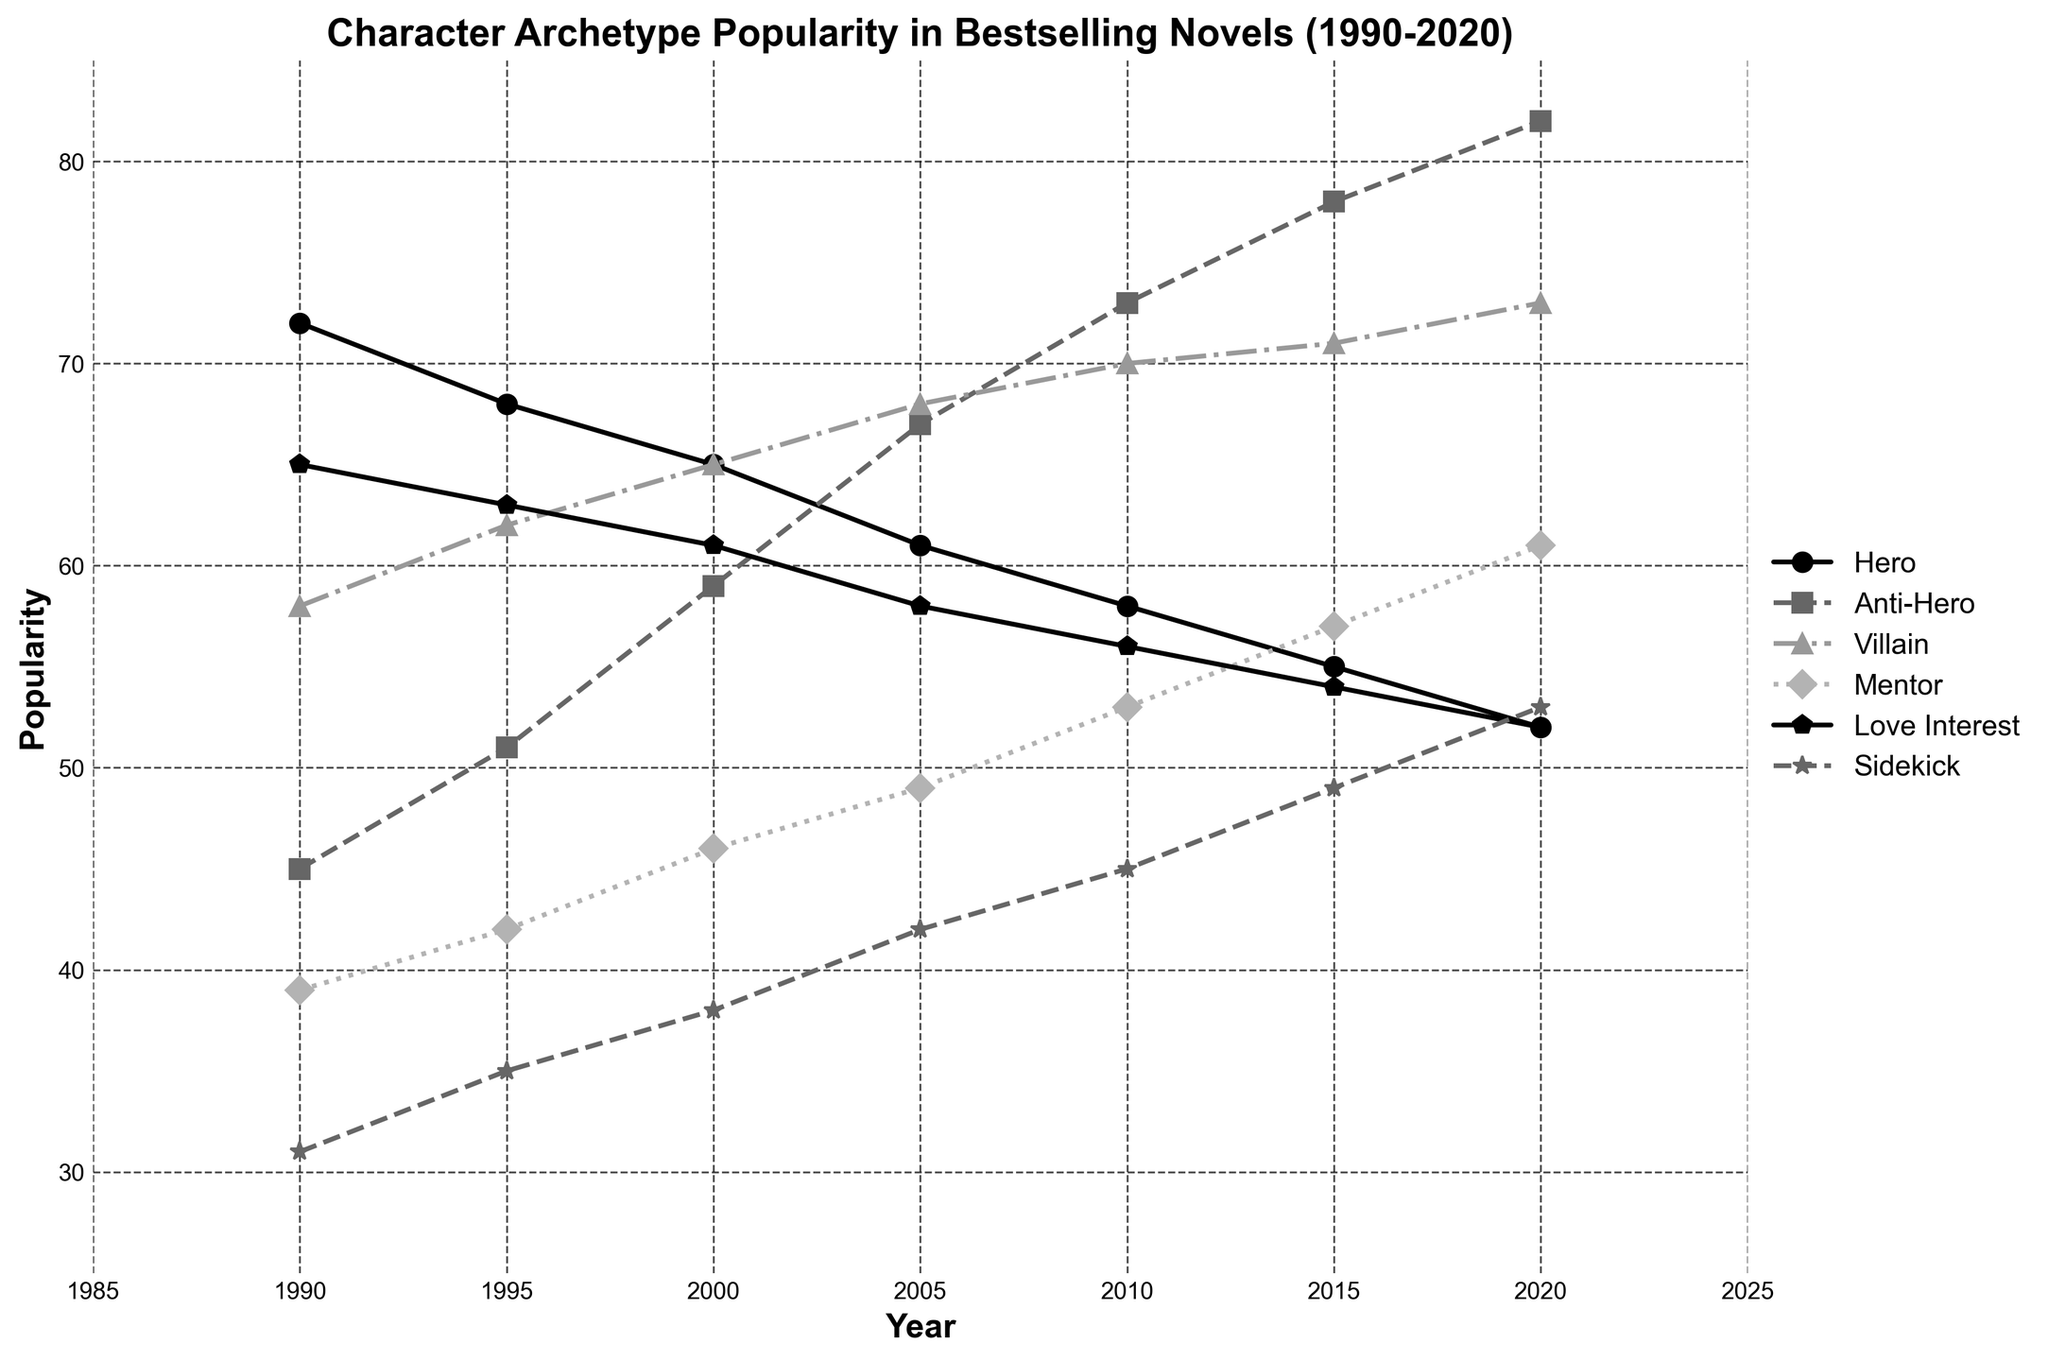What's the most popular character archetype throughout the entire time period? Look for the archetype with the highest overall popularity values in multiple years. Anti-Hero is consistently increasing and by 2020 reaches 82, while other archetypes like Hero decline.
Answer: Anti-Hero Which year does the Mentor character archetype surpass the Hero archetype in popularity? Identify the point where the Mentor's popularity line crosses above the Hero's popularity line. In 2020, Mentor has a popularity of 61, while Hero has dropped to 52.
Answer: 2020 Compare the popularity of the Villain archetype in 1995 and 2020. Which year is it more popular, and by how much? Check the values for Villain in both years. In 1995, it’s 62, and by 2020 it has increased to 73. Calculate the difference (73 - 62).
Answer: 2020 by 11 What is the average popularity of the Sidekick archetype from 1990 to 2020? Add the popularity values for Sidekick from 1990, 1995, 2000, 2005, 2010, 2015, and 2020 and divide by 7 (31 + 35 + 38 + 42 + 45 + 49 + 53) / 7.
Answer: 42.6 Identify the year when the Love Interest archetype starts its decline. Observe the Love Interest line to see when it starts decreasing. It peaks in 1990 at 65 and decreases to 63 in 1995.
Answer: 1990 Which two character archetypes are closest in popularity in 2005, and what's their difference? Check the 2005 values. Hero is 61, Anti-Hero is 67, Villain is 68, Mentor is 49, Love Interest is 58, and Sidekick is 42. Hero and Love Interest are closest at 61 and 58; their difference is 61 - 58.
Answer: Hero and Love Interest, 3 By how much did the popularity of the Anti-Hero archetype change from 1990 to 2020? Subtract the 1990 popularity value of Anti-Hero from the 2020 value (82 - 45).
Answer: 37 Which archetype had the least change in popularity from 1990 to 2020? Calculate changes for each archetype by subtracting 1990 values from 2020 values: Hero (52-72), Anti-Hero (82-45), Villain (73-58), Mentor (61-39), Love Interest (52-65), Sidekick (53-31). Mentor has the least change (61-39).
Answer: Mentor What is the difference in popularity between the Hero and Villain archetypes in 2010? Look at 2010 values: Hero is 58, Villain is 70. Calculate 70 - 58.
Answer: 12 